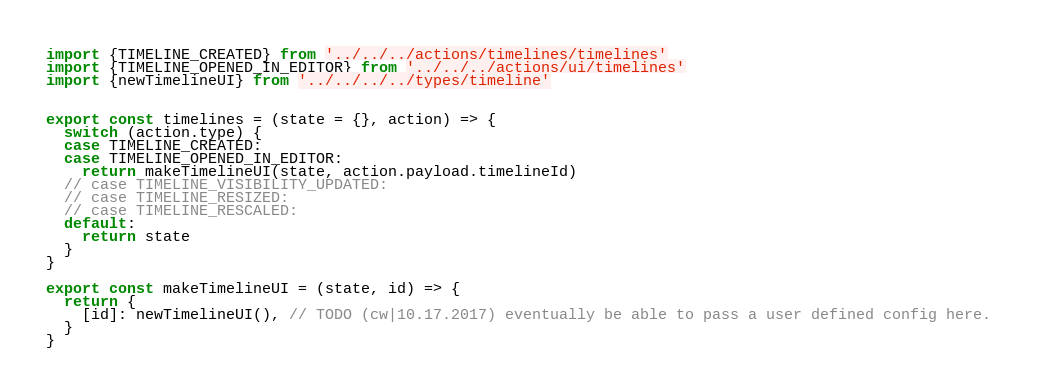Convert code to text. <code><loc_0><loc_0><loc_500><loc_500><_JavaScript_>import {TIMELINE_CREATED} from '../../../actions/timelines/timelines'
import {TIMELINE_OPENED_IN_EDITOR} from '../../../actions/ui/timelines'
import {newTimelineUI} from '../../../../types/timeline'


export const timelines = (state = {}, action) => {
  switch (action.type) {
  case TIMELINE_CREATED:
  case TIMELINE_OPENED_IN_EDITOR:
    return makeTimelineUI(state, action.payload.timelineId)
  // case TIMELINE_VISIBILITY_UPDATED:
  // case TIMELINE_RESIZED:
  // case TIMELINE_RESCALED:
  default:
    return state
  }
}

export const makeTimelineUI = (state, id) => {
  return {
    [id]: newTimelineUI(), // TODO (cw|10.17.2017) eventually be able to pass a user defined config here.
  }
}
</code> 